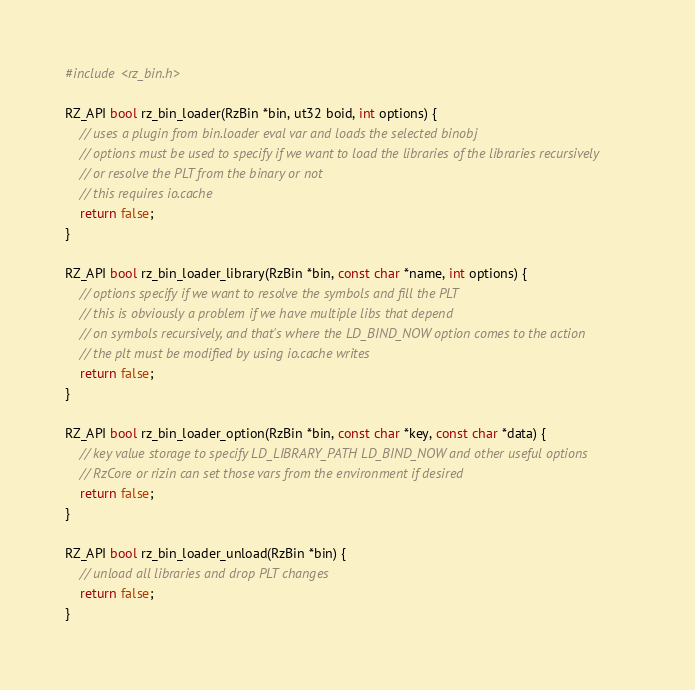<code> <loc_0><loc_0><loc_500><loc_500><_C_>
#include <rz_bin.h>

RZ_API bool rz_bin_loader(RzBin *bin, ut32 boid, int options) {
	// uses a plugin from bin.loader eval var and loads the selected binobj
	// options must be used to specify if we want to load the libraries of the libraries recursively
	// or resolve the PLT from the binary or not
	// this requires io.cache
	return false;
}

RZ_API bool rz_bin_loader_library(RzBin *bin, const char *name, int options) {
	// options specify if we want to resolve the symbols and fill the PLT
	// this is obviously a problem if we have multiple libs that depend
	// on symbols recursively, and that's where the LD_BIND_NOW option comes to the action
	// the plt must be modified by using io.cache writes
	return false;
}

RZ_API bool rz_bin_loader_option(RzBin *bin, const char *key, const char *data) {
	// key value storage to specify LD_LIBRARY_PATH LD_BIND_NOW and other useful options
	// RzCore or rizin can set those vars from the environment if desired
	return false;
}

RZ_API bool rz_bin_loader_unload(RzBin *bin) {
	// unload all libraries and drop PLT changes
	return false;
}
</code> 